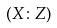<formula> <loc_0><loc_0><loc_500><loc_500>( X \colon Z )</formula> 